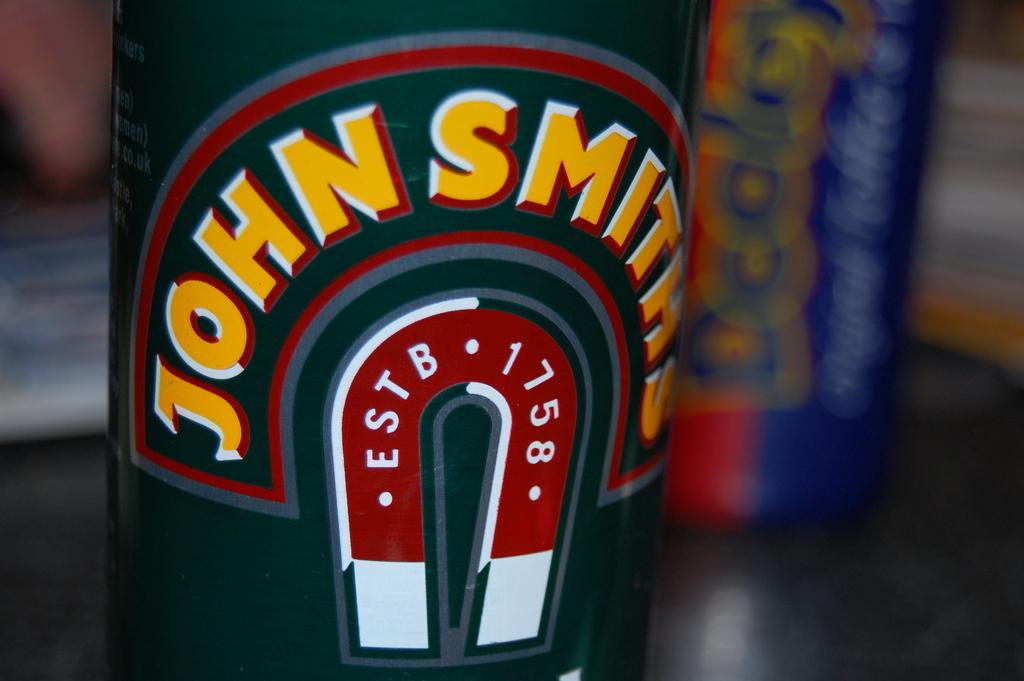<image>
Describe the image concisely. A label indicates John Smiths was established in 1758. 